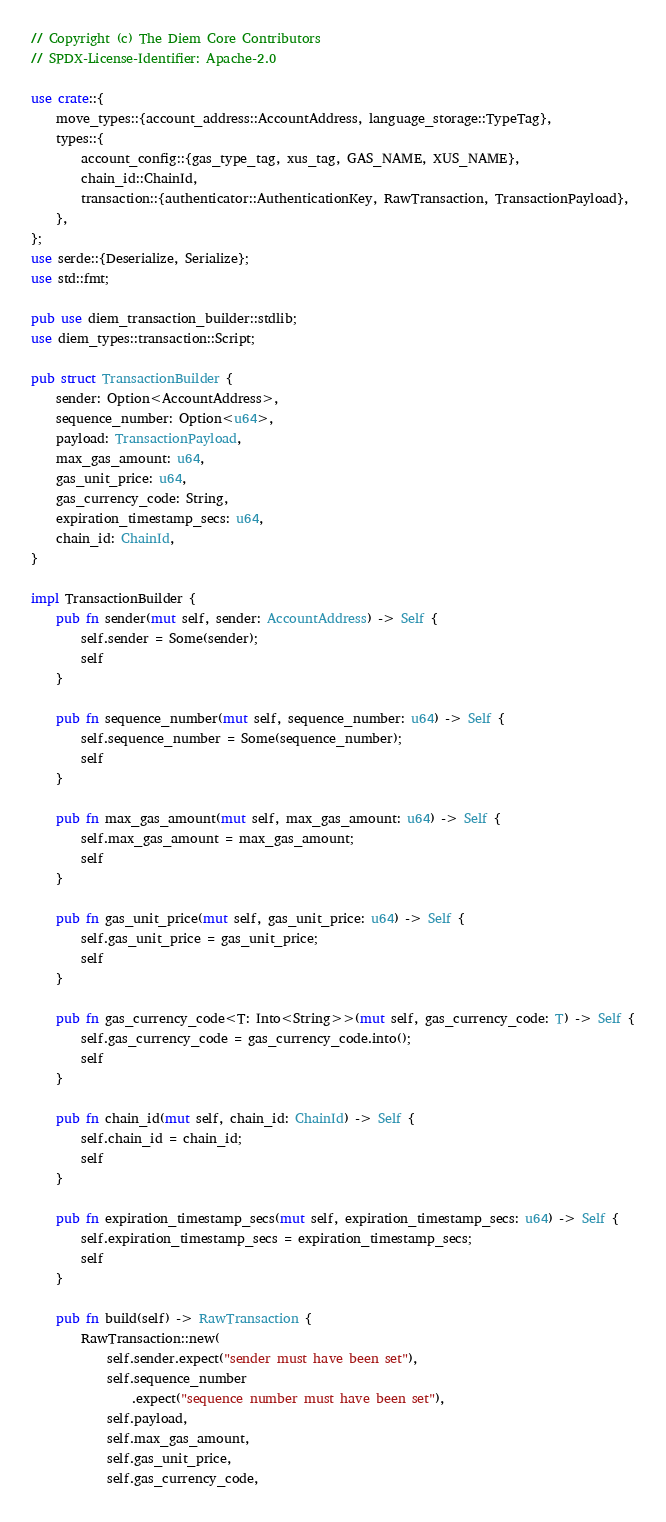<code> <loc_0><loc_0><loc_500><loc_500><_Rust_>// Copyright (c) The Diem Core Contributors
// SPDX-License-Identifier: Apache-2.0

use crate::{
    move_types::{account_address::AccountAddress, language_storage::TypeTag},
    types::{
        account_config::{gas_type_tag, xus_tag, GAS_NAME, XUS_NAME},
        chain_id::ChainId,
        transaction::{authenticator::AuthenticationKey, RawTransaction, TransactionPayload},
    },
};
use serde::{Deserialize, Serialize};
use std::fmt;

pub use diem_transaction_builder::stdlib;
use diem_types::transaction::Script;

pub struct TransactionBuilder {
    sender: Option<AccountAddress>,
    sequence_number: Option<u64>,
    payload: TransactionPayload,
    max_gas_amount: u64,
    gas_unit_price: u64,
    gas_currency_code: String,
    expiration_timestamp_secs: u64,
    chain_id: ChainId,
}

impl TransactionBuilder {
    pub fn sender(mut self, sender: AccountAddress) -> Self {
        self.sender = Some(sender);
        self
    }

    pub fn sequence_number(mut self, sequence_number: u64) -> Self {
        self.sequence_number = Some(sequence_number);
        self
    }

    pub fn max_gas_amount(mut self, max_gas_amount: u64) -> Self {
        self.max_gas_amount = max_gas_amount;
        self
    }

    pub fn gas_unit_price(mut self, gas_unit_price: u64) -> Self {
        self.gas_unit_price = gas_unit_price;
        self
    }

    pub fn gas_currency_code<T: Into<String>>(mut self, gas_currency_code: T) -> Self {
        self.gas_currency_code = gas_currency_code.into();
        self
    }

    pub fn chain_id(mut self, chain_id: ChainId) -> Self {
        self.chain_id = chain_id;
        self
    }

    pub fn expiration_timestamp_secs(mut self, expiration_timestamp_secs: u64) -> Self {
        self.expiration_timestamp_secs = expiration_timestamp_secs;
        self
    }

    pub fn build(self) -> RawTransaction {
        RawTransaction::new(
            self.sender.expect("sender must have been set"),
            self.sequence_number
                .expect("sequence number must have been set"),
            self.payload,
            self.max_gas_amount,
            self.gas_unit_price,
            self.gas_currency_code,</code> 